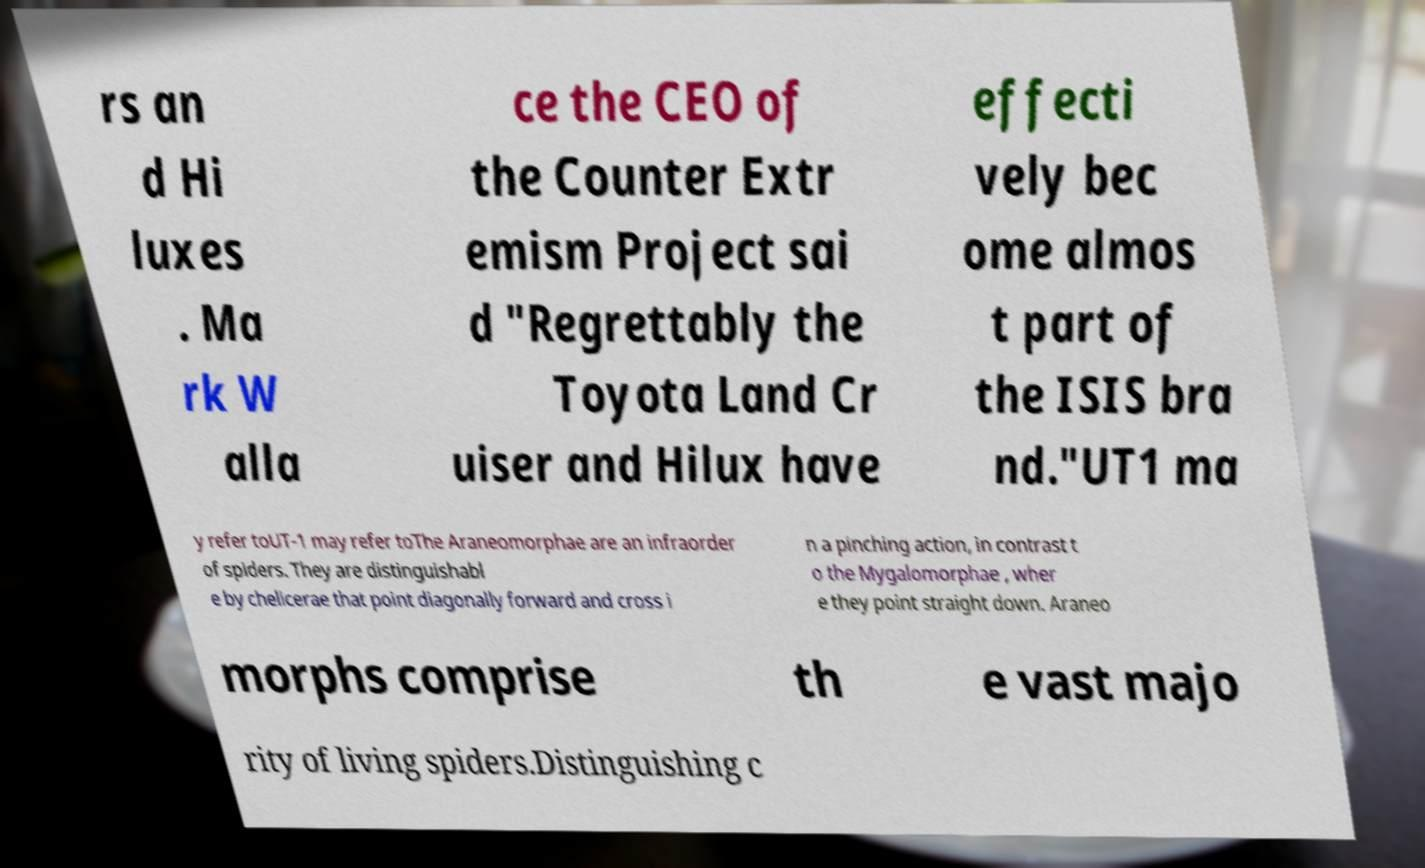Could you extract and type out the text from this image? rs an d Hi luxes . Ma rk W alla ce the CEO of the Counter Extr emism Project sai d "Regrettably the Toyota Land Cr uiser and Hilux have effecti vely bec ome almos t part of the ISIS bra nd."UT1 ma y refer toUT-1 may refer toThe Araneomorphae are an infraorder of spiders. They are distinguishabl e by chelicerae that point diagonally forward and cross i n a pinching action, in contrast t o the Mygalomorphae , wher e they point straight down. Araneo morphs comprise th e vast majo rity of living spiders.Distinguishing c 